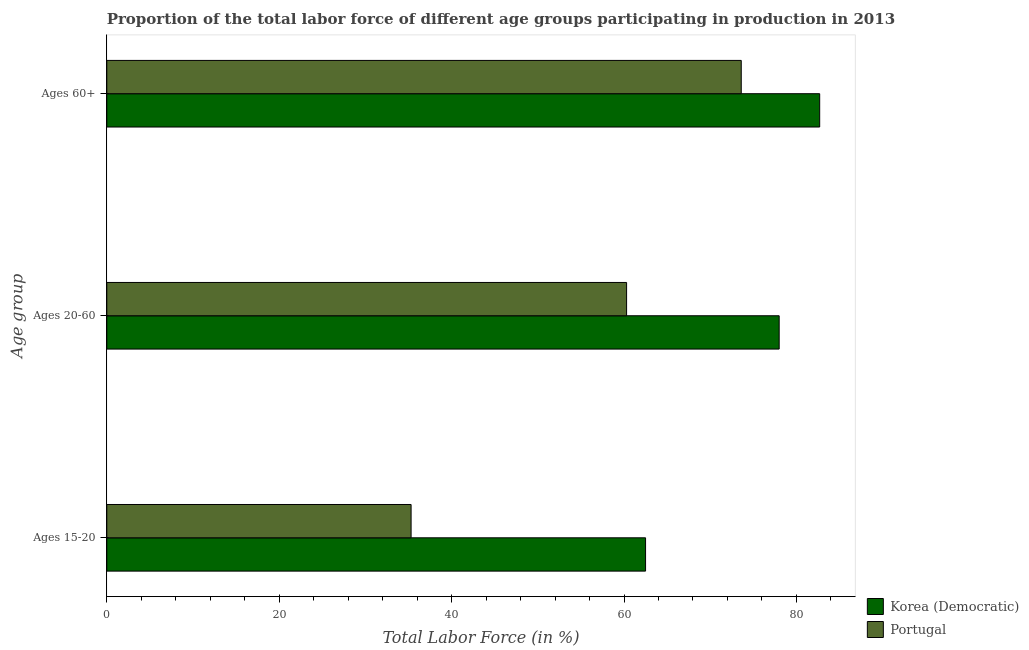How many groups of bars are there?
Keep it short and to the point. 3. Are the number of bars per tick equal to the number of legend labels?
Give a very brief answer. Yes. Are the number of bars on each tick of the Y-axis equal?
Provide a succinct answer. Yes. How many bars are there on the 1st tick from the top?
Provide a short and direct response. 2. What is the label of the 3rd group of bars from the top?
Offer a very short reply. Ages 15-20. What is the percentage of labor force within the age group 20-60 in Portugal?
Make the answer very short. 60.3. Across all countries, what is the maximum percentage of labor force within the age group 20-60?
Make the answer very short. 78. Across all countries, what is the minimum percentage of labor force above age 60?
Offer a terse response. 73.6. In which country was the percentage of labor force above age 60 maximum?
Keep it short and to the point. Korea (Democratic). What is the total percentage of labor force within the age group 15-20 in the graph?
Offer a terse response. 97.8. What is the difference between the percentage of labor force above age 60 in Portugal and that in Korea (Democratic)?
Your response must be concise. -9.1. What is the difference between the percentage of labor force within the age group 20-60 in Portugal and the percentage of labor force within the age group 15-20 in Korea (Democratic)?
Offer a very short reply. -2.2. What is the average percentage of labor force within the age group 15-20 per country?
Your answer should be compact. 48.9. What is the difference between the percentage of labor force within the age group 20-60 and percentage of labor force above age 60 in Korea (Democratic)?
Your response must be concise. -4.7. What is the ratio of the percentage of labor force within the age group 15-20 in Portugal to that in Korea (Democratic)?
Give a very brief answer. 0.56. Is the percentage of labor force above age 60 in Portugal less than that in Korea (Democratic)?
Offer a very short reply. Yes. What is the difference between the highest and the second highest percentage of labor force within the age group 15-20?
Provide a succinct answer. 27.2. What is the difference between the highest and the lowest percentage of labor force above age 60?
Make the answer very short. 9.1. What does the 2nd bar from the top in Ages 60+ represents?
Offer a very short reply. Korea (Democratic). What does the 1st bar from the bottom in Ages 60+ represents?
Provide a short and direct response. Korea (Democratic). Are all the bars in the graph horizontal?
Give a very brief answer. Yes. How many countries are there in the graph?
Your answer should be very brief. 2. Are the values on the major ticks of X-axis written in scientific E-notation?
Provide a succinct answer. No. Does the graph contain any zero values?
Ensure brevity in your answer.  No. How are the legend labels stacked?
Your response must be concise. Vertical. What is the title of the graph?
Ensure brevity in your answer.  Proportion of the total labor force of different age groups participating in production in 2013. What is the label or title of the Y-axis?
Your answer should be very brief. Age group. What is the Total Labor Force (in %) in Korea (Democratic) in Ages 15-20?
Your response must be concise. 62.5. What is the Total Labor Force (in %) in Portugal in Ages 15-20?
Make the answer very short. 35.3. What is the Total Labor Force (in %) of Portugal in Ages 20-60?
Offer a terse response. 60.3. What is the Total Labor Force (in %) of Korea (Democratic) in Ages 60+?
Your answer should be compact. 82.7. What is the Total Labor Force (in %) in Portugal in Ages 60+?
Offer a very short reply. 73.6. Across all Age group, what is the maximum Total Labor Force (in %) of Korea (Democratic)?
Make the answer very short. 82.7. Across all Age group, what is the maximum Total Labor Force (in %) in Portugal?
Keep it short and to the point. 73.6. Across all Age group, what is the minimum Total Labor Force (in %) of Korea (Democratic)?
Your response must be concise. 62.5. Across all Age group, what is the minimum Total Labor Force (in %) in Portugal?
Your response must be concise. 35.3. What is the total Total Labor Force (in %) in Korea (Democratic) in the graph?
Your response must be concise. 223.2. What is the total Total Labor Force (in %) in Portugal in the graph?
Give a very brief answer. 169.2. What is the difference between the Total Labor Force (in %) of Korea (Democratic) in Ages 15-20 and that in Ages 20-60?
Your answer should be compact. -15.5. What is the difference between the Total Labor Force (in %) of Korea (Democratic) in Ages 15-20 and that in Ages 60+?
Your answer should be very brief. -20.2. What is the difference between the Total Labor Force (in %) of Portugal in Ages 15-20 and that in Ages 60+?
Ensure brevity in your answer.  -38.3. What is the difference between the Total Labor Force (in %) of Korea (Democratic) in Ages 20-60 and that in Ages 60+?
Offer a terse response. -4.7. What is the difference between the Total Labor Force (in %) in Korea (Democratic) in Ages 15-20 and the Total Labor Force (in %) in Portugal in Ages 60+?
Your response must be concise. -11.1. What is the average Total Labor Force (in %) in Korea (Democratic) per Age group?
Your response must be concise. 74.4. What is the average Total Labor Force (in %) of Portugal per Age group?
Keep it short and to the point. 56.4. What is the difference between the Total Labor Force (in %) of Korea (Democratic) and Total Labor Force (in %) of Portugal in Ages 15-20?
Keep it short and to the point. 27.2. What is the ratio of the Total Labor Force (in %) in Korea (Democratic) in Ages 15-20 to that in Ages 20-60?
Offer a very short reply. 0.8. What is the ratio of the Total Labor Force (in %) of Portugal in Ages 15-20 to that in Ages 20-60?
Provide a short and direct response. 0.59. What is the ratio of the Total Labor Force (in %) of Korea (Democratic) in Ages 15-20 to that in Ages 60+?
Your answer should be very brief. 0.76. What is the ratio of the Total Labor Force (in %) of Portugal in Ages 15-20 to that in Ages 60+?
Make the answer very short. 0.48. What is the ratio of the Total Labor Force (in %) in Korea (Democratic) in Ages 20-60 to that in Ages 60+?
Your answer should be very brief. 0.94. What is the ratio of the Total Labor Force (in %) of Portugal in Ages 20-60 to that in Ages 60+?
Ensure brevity in your answer.  0.82. What is the difference between the highest and the second highest Total Labor Force (in %) in Korea (Democratic)?
Ensure brevity in your answer.  4.7. What is the difference between the highest and the lowest Total Labor Force (in %) in Korea (Democratic)?
Ensure brevity in your answer.  20.2. What is the difference between the highest and the lowest Total Labor Force (in %) in Portugal?
Your response must be concise. 38.3. 